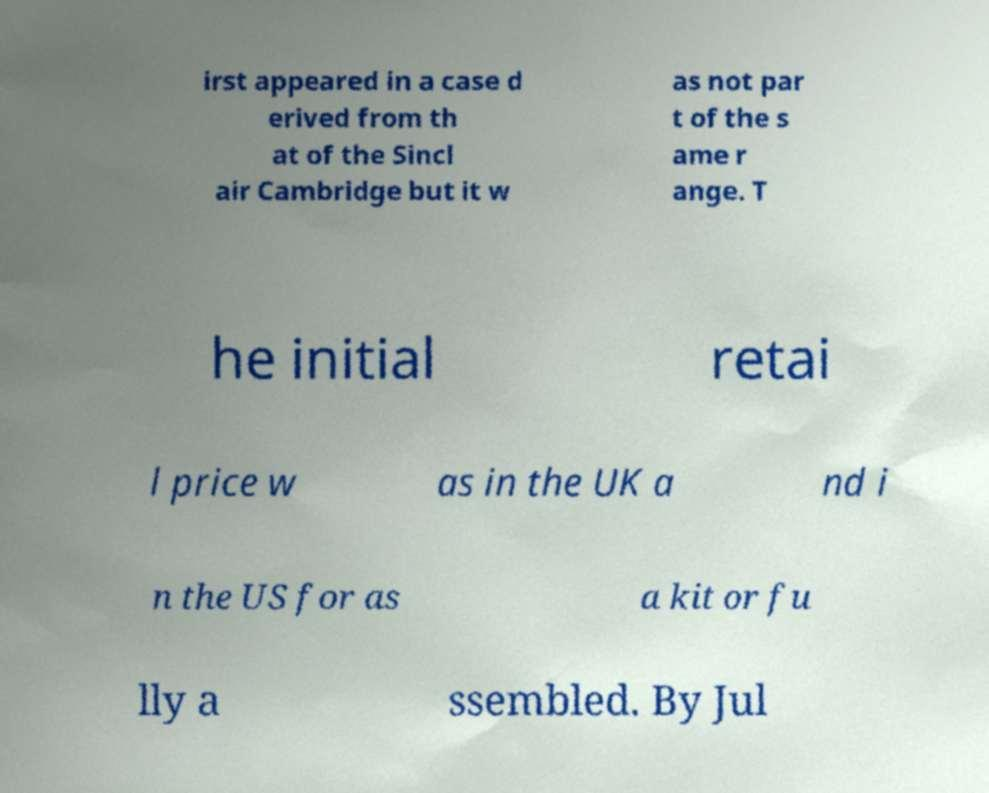For documentation purposes, I need the text within this image transcribed. Could you provide that? irst appeared in a case d erived from th at of the Sincl air Cambridge but it w as not par t of the s ame r ange. T he initial retai l price w as in the UK a nd i n the US for as a kit or fu lly a ssembled. By Jul 